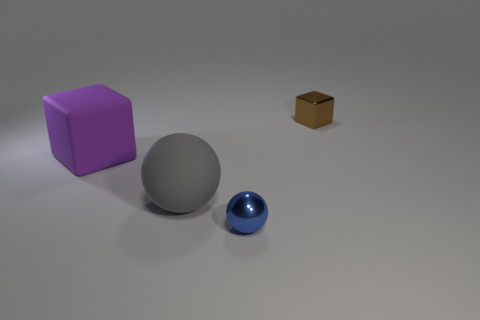Does the large matte cube have the same color as the metallic sphere?
Keep it short and to the point. No. Is the number of red rubber spheres greater than the number of small metal balls?
Make the answer very short. No. How many other things are there of the same material as the big gray sphere?
Your response must be concise. 1. There is a thing in front of the matte object that is in front of the large purple thing; how many large matte cubes are to the right of it?
Give a very brief answer. 0. What number of rubber things are either big purple objects or large spheres?
Your response must be concise. 2. There is a shiny object in front of the block behind the matte block; what size is it?
Ensure brevity in your answer.  Small. Is the color of the small thing to the left of the small brown metallic thing the same as the matte object on the right side of the large rubber block?
Your answer should be compact. No. There is a thing that is behind the large gray rubber thing and on the right side of the purple rubber block; what is its color?
Keep it short and to the point. Brown. Is the tiny blue thing made of the same material as the big gray ball?
Offer a terse response. No. What number of large things are either purple matte objects or matte objects?
Offer a very short reply. 2. 